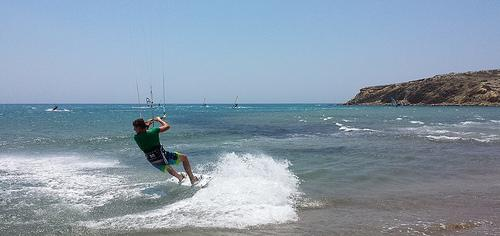What is the state of the sky in the image? The sky is a hazy light blue. Provide a detailed description of the water in the image. The water in the image is turquoise and has calm, blue ocean waves with white splashes and some small cresting waves in the distance. What sport is the person participating in? The person is participating in windsurfing or parasailing. What is the main color of the mountain in the image? The main color of the mountain is green. Explain the primary features of the surfer in the image. The surfer is an adult white male with dark hair, wearing a green shirt and multicolored swim trunks. How many mountains can you find in the image? There are 10 mountains in the image. Mention some information about the rock formation in the background of the image. The rock formation in the background is a rocky point, brown and gray in color, and close to the water. Identify the primary activity taking place in this image. A man is windsurfing in the ocean. What is the surfer attached to around his waist? The surfer is attached to a safety harness around his waist. Explain what is happening around the edge of a nearby wave. There is a white splash at the edge of a nearby wave, creating bright white waves of water. Check out the vibrant coral reef teeming with colorful fish just below the calm blue ocean water. Can you see the striped clownfish? No coral reef or fish are mentioned in the list of image objects, making this instruction misleading. Which environmental feature contrasts the calm blue ocean water? The big green mountain in the corner. What type of sport does the image depict? Windsurfing Evaluate the sky's appearance in the image. The sky is hazy and light blue. What color is the mountain located in the image's corner? Green Can you spot the flock of seagulls flying above the ocean? There is a seagull with a red beak leading the group. No, it's not mentioned in the image. Describe the shape and color of the bar that the man is holding. The bar is straight and its color cannot be determined due to the limited image information. Describe the main object in the image performing an activity. A man is windsurfing, leaning backwards, wearing a green shirt and multicolored shorts. Give a poetic description of the landscape in the image. Amidst the sun's gentle embrace, green cliffs stand sentinel upon the tranquil azure, a canvas for the windsurfer's art. A tall palm tree stands near the brown cliff, swaying gently in the breeze. Its coconuts are almost ready to fall. There is no mention of a palm tree or coconuts in the list of image objects, so this instruction is misleading. Is the surfer creating a wave? If yes, describe the wave. Yes, the surfer is creating a splashing white wave. Choose the correct description from the Multi-choice options: b) An adult white male surfer is windsurfing in the ocean. Identify the brown environmental feature near the water. It is a brown cliff. Create a short story that includes key elements from the image. Once upon a sunlit day on the turquoise sea, a daring windsurfer harnessed the wind's power, gliding across the crystalline surface. Beneath the vibrant green cliffs, he reveled at the world around him, becoming one with the elements as the hazy blue sky watched on. State one key characteristic of the man's shorts. The shorts are green and black. What type of environment is the windsurfer in? The windsurfer is in a coastal environment with a cliff and ocean. Describe the position of both feet on the board. Both feet are on the board, but the exact stance cannot be determined from the provided information. Describe the ocean water's color and state. The ocean water is calm and blue. What feature can be seen in the background behind the surfer? A rocky point. Please provide a stylish caption for the image. Windsurfer Conquering the Azure Waves Beneath Majestic Green Cliffs 